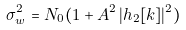Convert formula to latex. <formula><loc_0><loc_0><loc_500><loc_500>\sigma _ { w } ^ { 2 } = N _ { 0 } ( 1 + A ^ { 2 } \, | h _ { 2 } [ k ] | ^ { 2 } )</formula> 